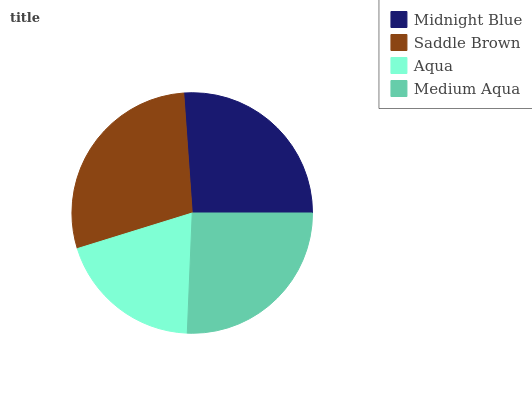Is Aqua the minimum?
Answer yes or no. Yes. Is Saddle Brown the maximum?
Answer yes or no. Yes. Is Saddle Brown the minimum?
Answer yes or no. No. Is Aqua the maximum?
Answer yes or no. No. Is Saddle Brown greater than Aqua?
Answer yes or no. Yes. Is Aqua less than Saddle Brown?
Answer yes or no. Yes. Is Aqua greater than Saddle Brown?
Answer yes or no. No. Is Saddle Brown less than Aqua?
Answer yes or no. No. Is Midnight Blue the high median?
Answer yes or no. Yes. Is Medium Aqua the low median?
Answer yes or no. Yes. Is Saddle Brown the high median?
Answer yes or no. No. Is Saddle Brown the low median?
Answer yes or no. No. 